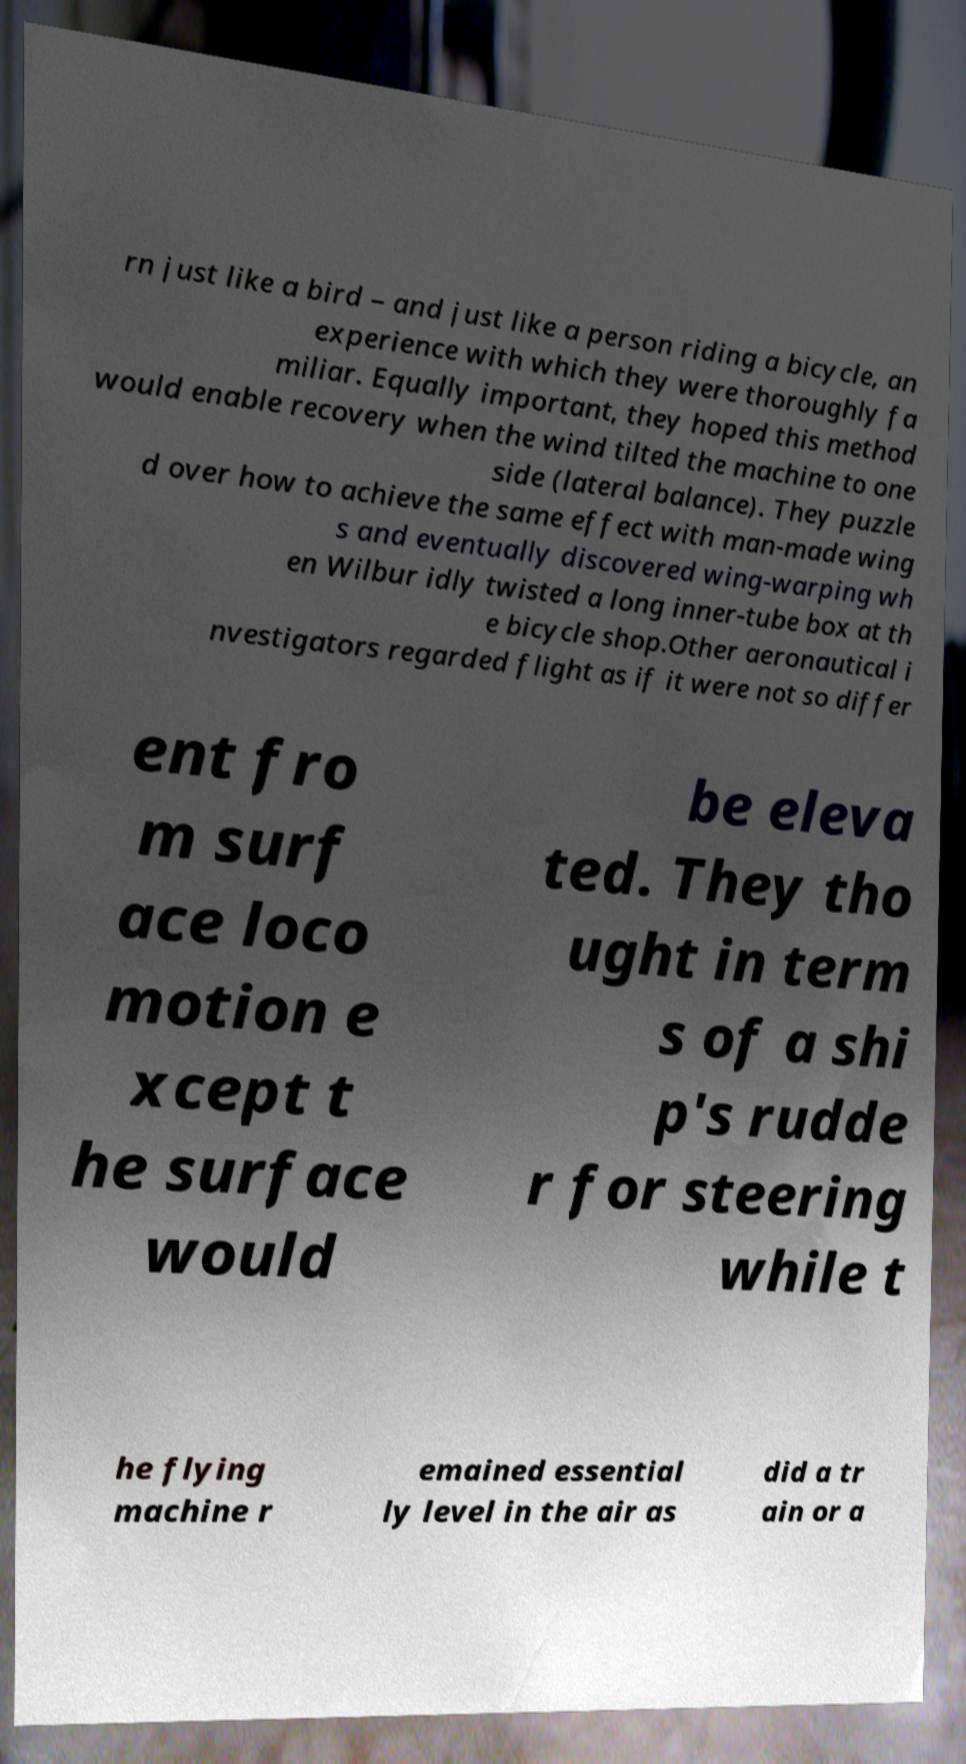Please read and relay the text visible in this image. What does it say? rn just like a bird – and just like a person riding a bicycle, an experience with which they were thoroughly fa miliar. Equally important, they hoped this method would enable recovery when the wind tilted the machine to one side (lateral balance). They puzzle d over how to achieve the same effect with man-made wing s and eventually discovered wing-warping wh en Wilbur idly twisted a long inner-tube box at th e bicycle shop.Other aeronautical i nvestigators regarded flight as if it were not so differ ent fro m surf ace loco motion e xcept t he surface would be eleva ted. They tho ught in term s of a shi p's rudde r for steering while t he flying machine r emained essential ly level in the air as did a tr ain or a 